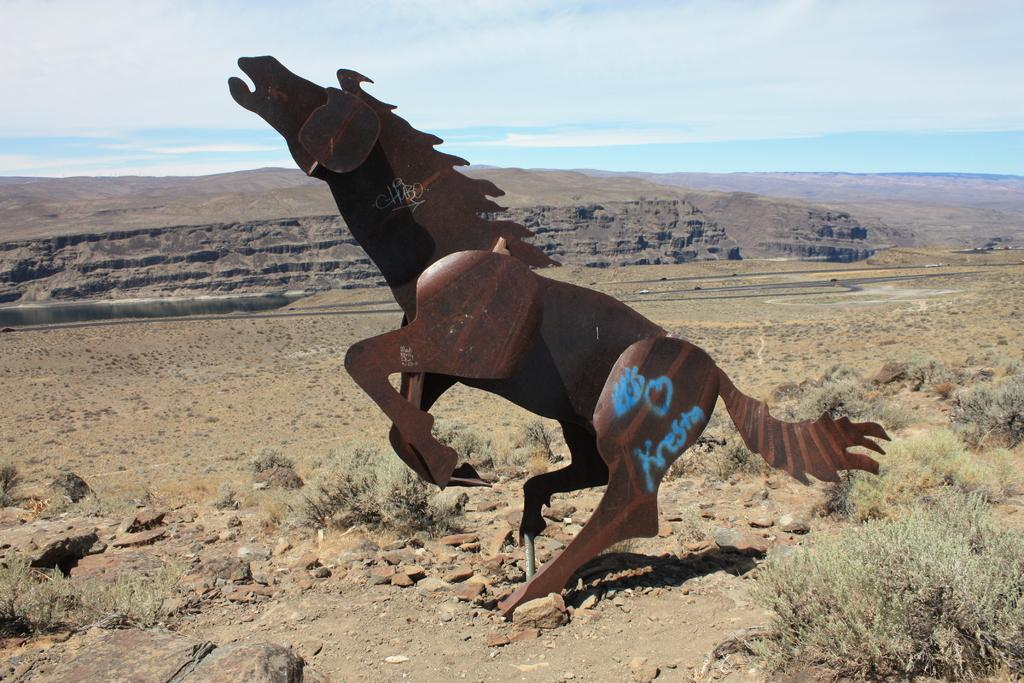What is the main subject of the image? There is a horse statue in the image. What can be seen on the ground in the image? There are stones on the ground in the image. What is visible in the background of the image? The sky is visible in the image. How would you describe the weather based on the sky in the image? The sky is cloudy in the image, which suggests overcast or potentially rainy weather. What type of heart is visible on the horse statue in the image? There is no heart present on the horse statue in the image. What is the secretary doing in the image? There is no secretary present in the image. 